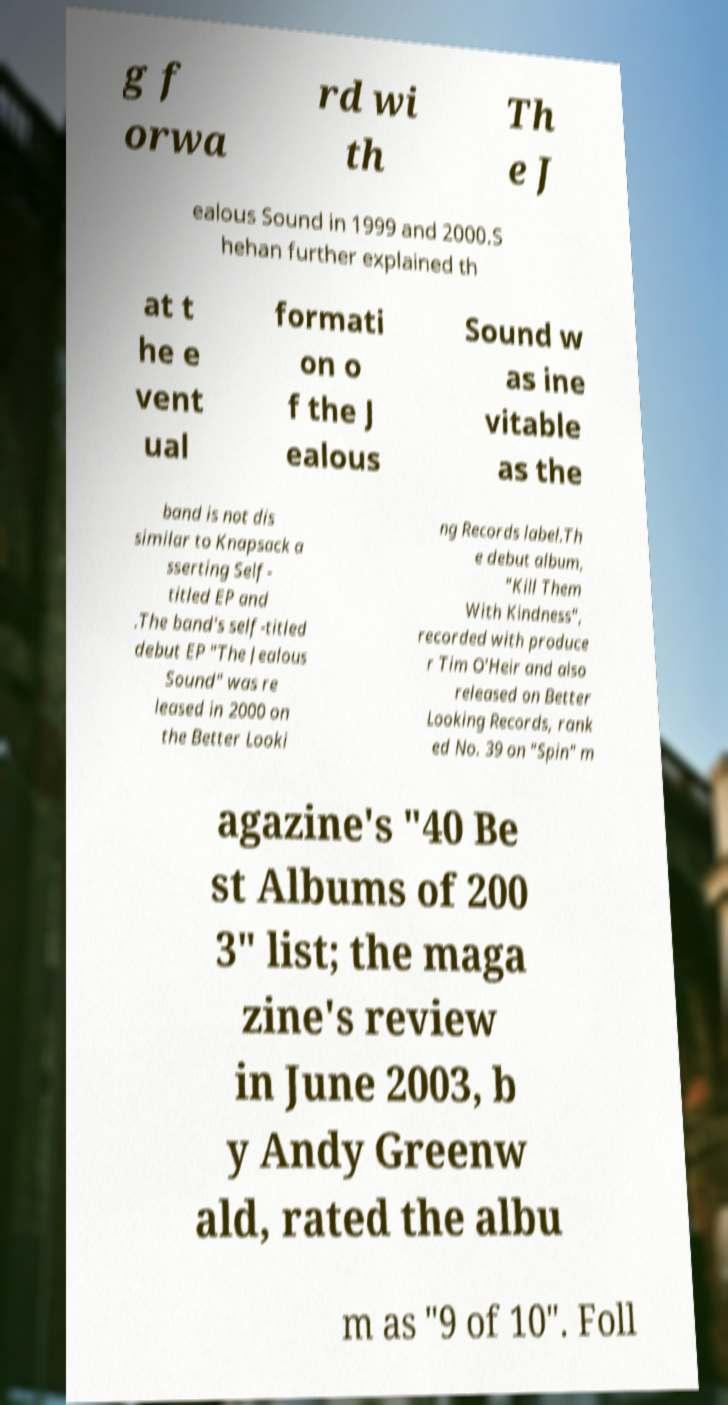I need the written content from this picture converted into text. Can you do that? g f orwa rd wi th Th e J ealous Sound in 1999 and 2000.S hehan further explained th at t he e vent ual formati on o f the J ealous Sound w as ine vitable as the band is not dis similar to Knapsack a sserting Self- titled EP and .The band's self-titled debut EP "The Jealous Sound" was re leased in 2000 on the Better Looki ng Records label.Th e debut album, "Kill Them With Kindness", recorded with produce r Tim O'Heir and also released on Better Looking Records, rank ed No. 39 on "Spin" m agazine's "40 Be st Albums of 200 3" list; the maga zine's review in June 2003, b y Andy Greenw ald, rated the albu m as "9 of 10". Foll 